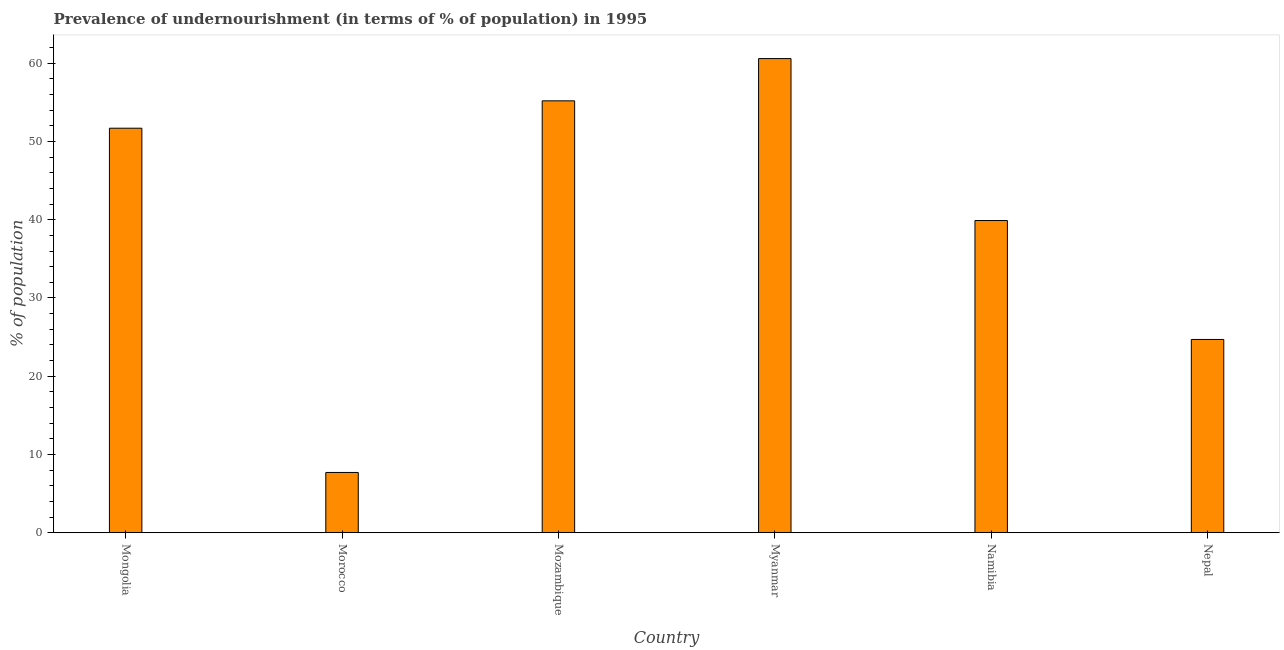What is the title of the graph?
Provide a succinct answer. Prevalence of undernourishment (in terms of % of population) in 1995. What is the label or title of the X-axis?
Make the answer very short. Country. What is the label or title of the Y-axis?
Give a very brief answer. % of population. What is the percentage of undernourished population in Mozambique?
Keep it short and to the point. 55.2. Across all countries, what is the maximum percentage of undernourished population?
Offer a very short reply. 60.6. Across all countries, what is the minimum percentage of undernourished population?
Your answer should be compact. 7.7. In which country was the percentage of undernourished population maximum?
Give a very brief answer. Myanmar. In which country was the percentage of undernourished population minimum?
Offer a very short reply. Morocco. What is the sum of the percentage of undernourished population?
Offer a very short reply. 239.8. What is the difference between the percentage of undernourished population in Mozambique and Nepal?
Provide a succinct answer. 30.5. What is the average percentage of undernourished population per country?
Offer a terse response. 39.97. What is the median percentage of undernourished population?
Keep it short and to the point. 45.8. What is the ratio of the percentage of undernourished population in Myanmar to that in Nepal?
Keep it short and to the point. 2.45. Is the sum of the percentage of undernourished population in Mongolia and Nepal greater than the maximum percentage of undernourished population across all countries?
Provide a short and direct response. Yes. What is the difference between the highest and the lowest percentage of undernourished population?
Provide a succinct answer. 52.9. How many bars are there?
Provide a succinct answer. 6. What is the difference between two consecutive major ticks on the Y-axis?
Your answer should be very brief. 10. Are the values on the major ticks of Y-axis written in scientific E-notation?
Ensure brevity in your answer.  No. What is the % of population in Mongolia?
Provide a short and direct response. 51.7. What is the % of population of Mozambique?
Your answer should be very brief. 55.2. What is the % of population in Myanmar?
Your response must be concise. 60.6. What is the % of population of Namibia?
Keep it short and to the point. 39.9. What is the % of population of Nepal?
Your answer should be very brief. 24.7. What is the difference between the % of population in Mongolia and Mozambique?
Provide a short and direct response. -3.5. What is the difference between the % of population in Mongolia and Nepal?
Ensure brevity in your answer.  27. What is the difference between the % of population in Morocco and Mozambique?
Make the answer very short. -47.5. What is the difference between the % of population in Morocco and Myanmar?
Your response must be concise. -52.9. What is the difference between the % of population in Morocco and Namibia?
Ensure brevity in your answer.  -32.2. What is the difference between the % of population in Morocco and Nepal?
Offer a terse response. -17. What is the difference between the % of population in Mozambique and Namibia?
Your answer should be compact. 15.3. What is the difference between the % of population in Mozambique and Nepal?
Your answer should be very brief. 30.5. What is the difference between the % of population in Myanmar and Namibia?
Provide a short and direct response. 20.7. What is the difference between the % of population in Myanmar and Nepal?
Provide a short and direct response. 35.9. What is the difference between the % of population in Namibia and Nepal?
Provide a succinct answer. 15.2. What is the ratio of the % of population in Mongolia to that in Morocco?
Ensure brevity in your answer.  6.71. What is the ratio of the % of population in Mongolia to that in Mozambique?
Your response must be concise. 0.94. What is the ratio of the % of population in Mongolia to that in Myanmar?
Ensure brevity in your answer.  0.85. What is the ratio of the % of population in Mongolia to that in Namibia?
Offer a terse response. 1.3. What is the ratio of the % of population in Mongolia to that in Nepal?
Ensure brevity in your answer.  2.09. What is the ratio of the % of population in Morocco to that in Mozambique?
Your response must be concise. 0.14. What is the ratio of the % of population in Morocco to that in Myanmar?
Keep it short and to the point. 0.13. What is the ratio of the % of population in Morocco to that in Namibia?
Ensure brevity in your answer.  0.19. What is the ratio of the % of population in Morocco to that in Nepal?
Give a very brief answer. 0.31. What is the ratio of the % of population in Mozambique to that in Myanmar?
Your answer should be very brief. 0.91. What is the ratio of the % of population in Mozambique to that in Namibia?
Provide a succinct answer. 1.38. What is the ratio of the % of population in Mozambique to that in Nepal?
Keep it short and to the point. 2.23. What is the ratio of the % of population in Myanmar to that in Namibia?
Make the answer very short. 1.52. What is the ratio of the % of population in Myanmar to that in Nepal?
Your response must be concise. 2.45. What is the ratio of the % of population in Namibia to that in Nepal?
Offer a very short reply. 1.61. 